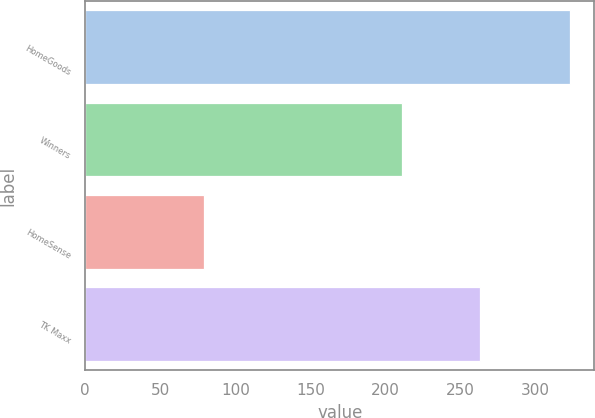Convert chart to OTSL. <chart><loc_0><loc_0><loc_500><loc_500><bar_chart><fcel>HomeGoods<fcel>Winners<fcel>HomeSense<fcel>TK Maxx<nl><fcel>323<fcel>211<fcel>79<fcel>263<nl></chart> 